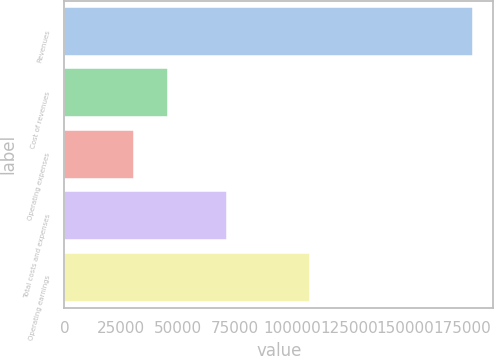Convert chart. <chart><loc_0><loc_0><loc_500><loc_500><bar_chart><fcel>Revenues<fcel>Cost of revenues<fcel>Operating expenses<fcel>Total costs and expenses<fcel>Operating earnings<nl><fcel>179520<fcel>45390.3<fcel>30487<fcel>71537<fcel>107983<nl></chart> 